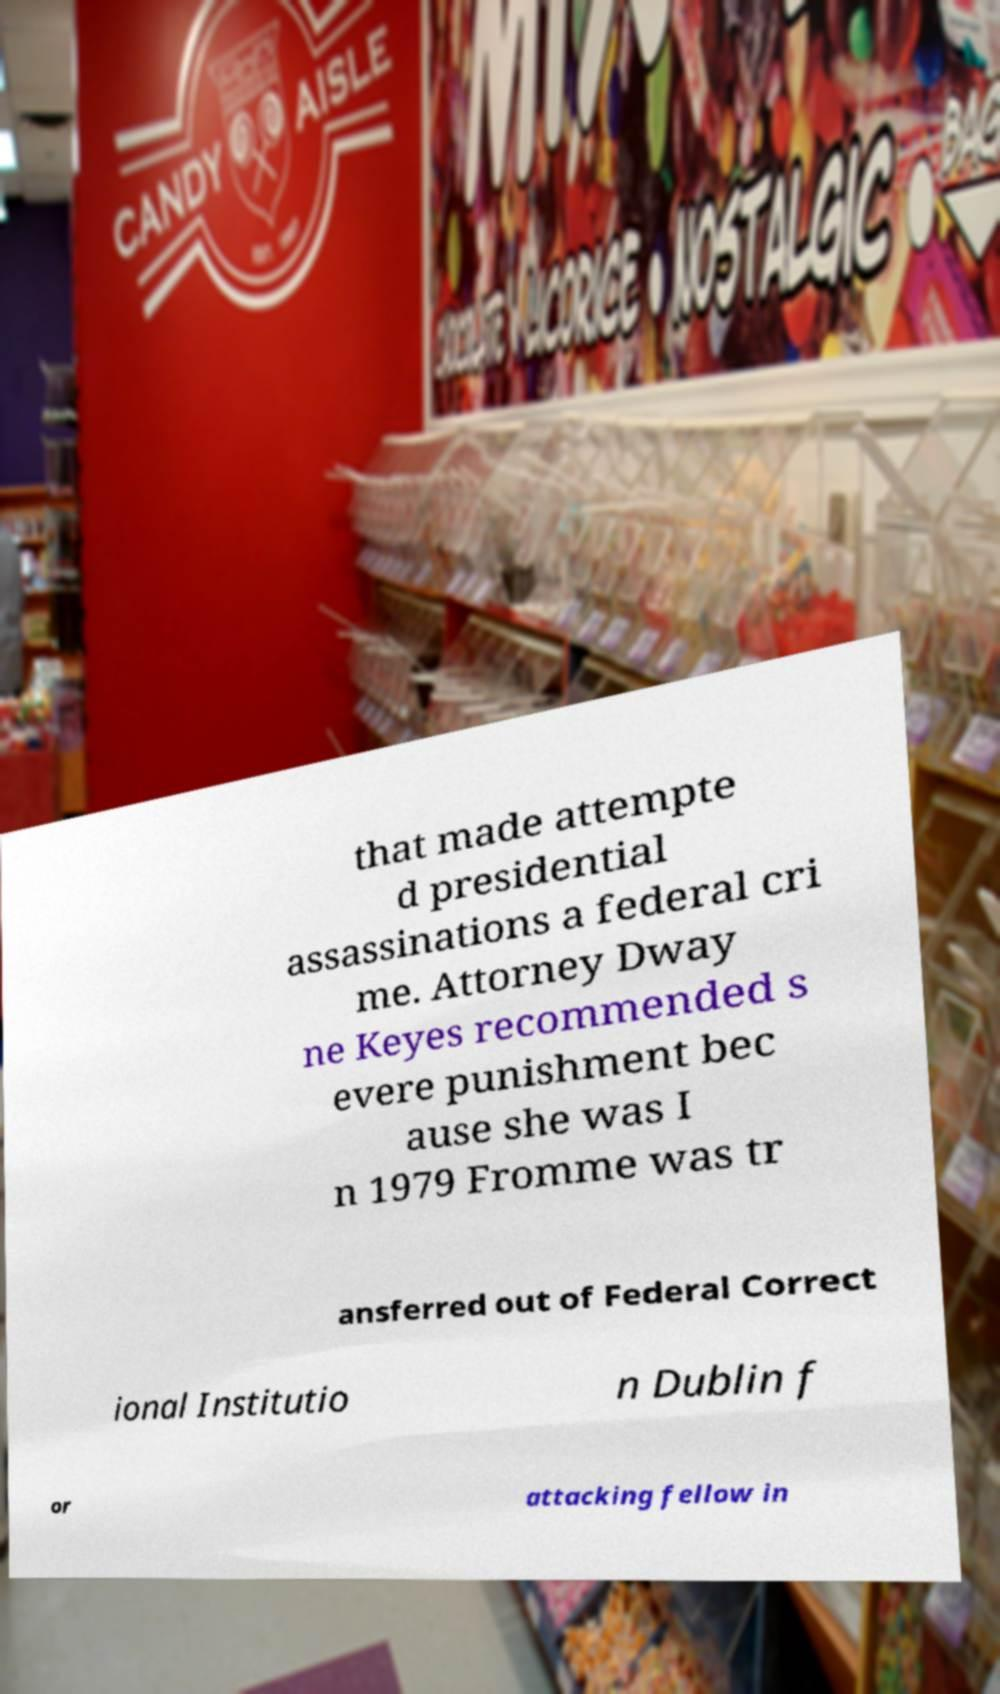For documentation purposes, I need the text within this image transcribed. Could you provide that? that made attempte d presidential assassinations a federal cri me. Attorney Dway ne Keyes recommended s evere punishment bec ause she was I n 1979 Fromme was tr ansferred out of Federal Correct ional Institutio n Dublin f or attacking fellow in 